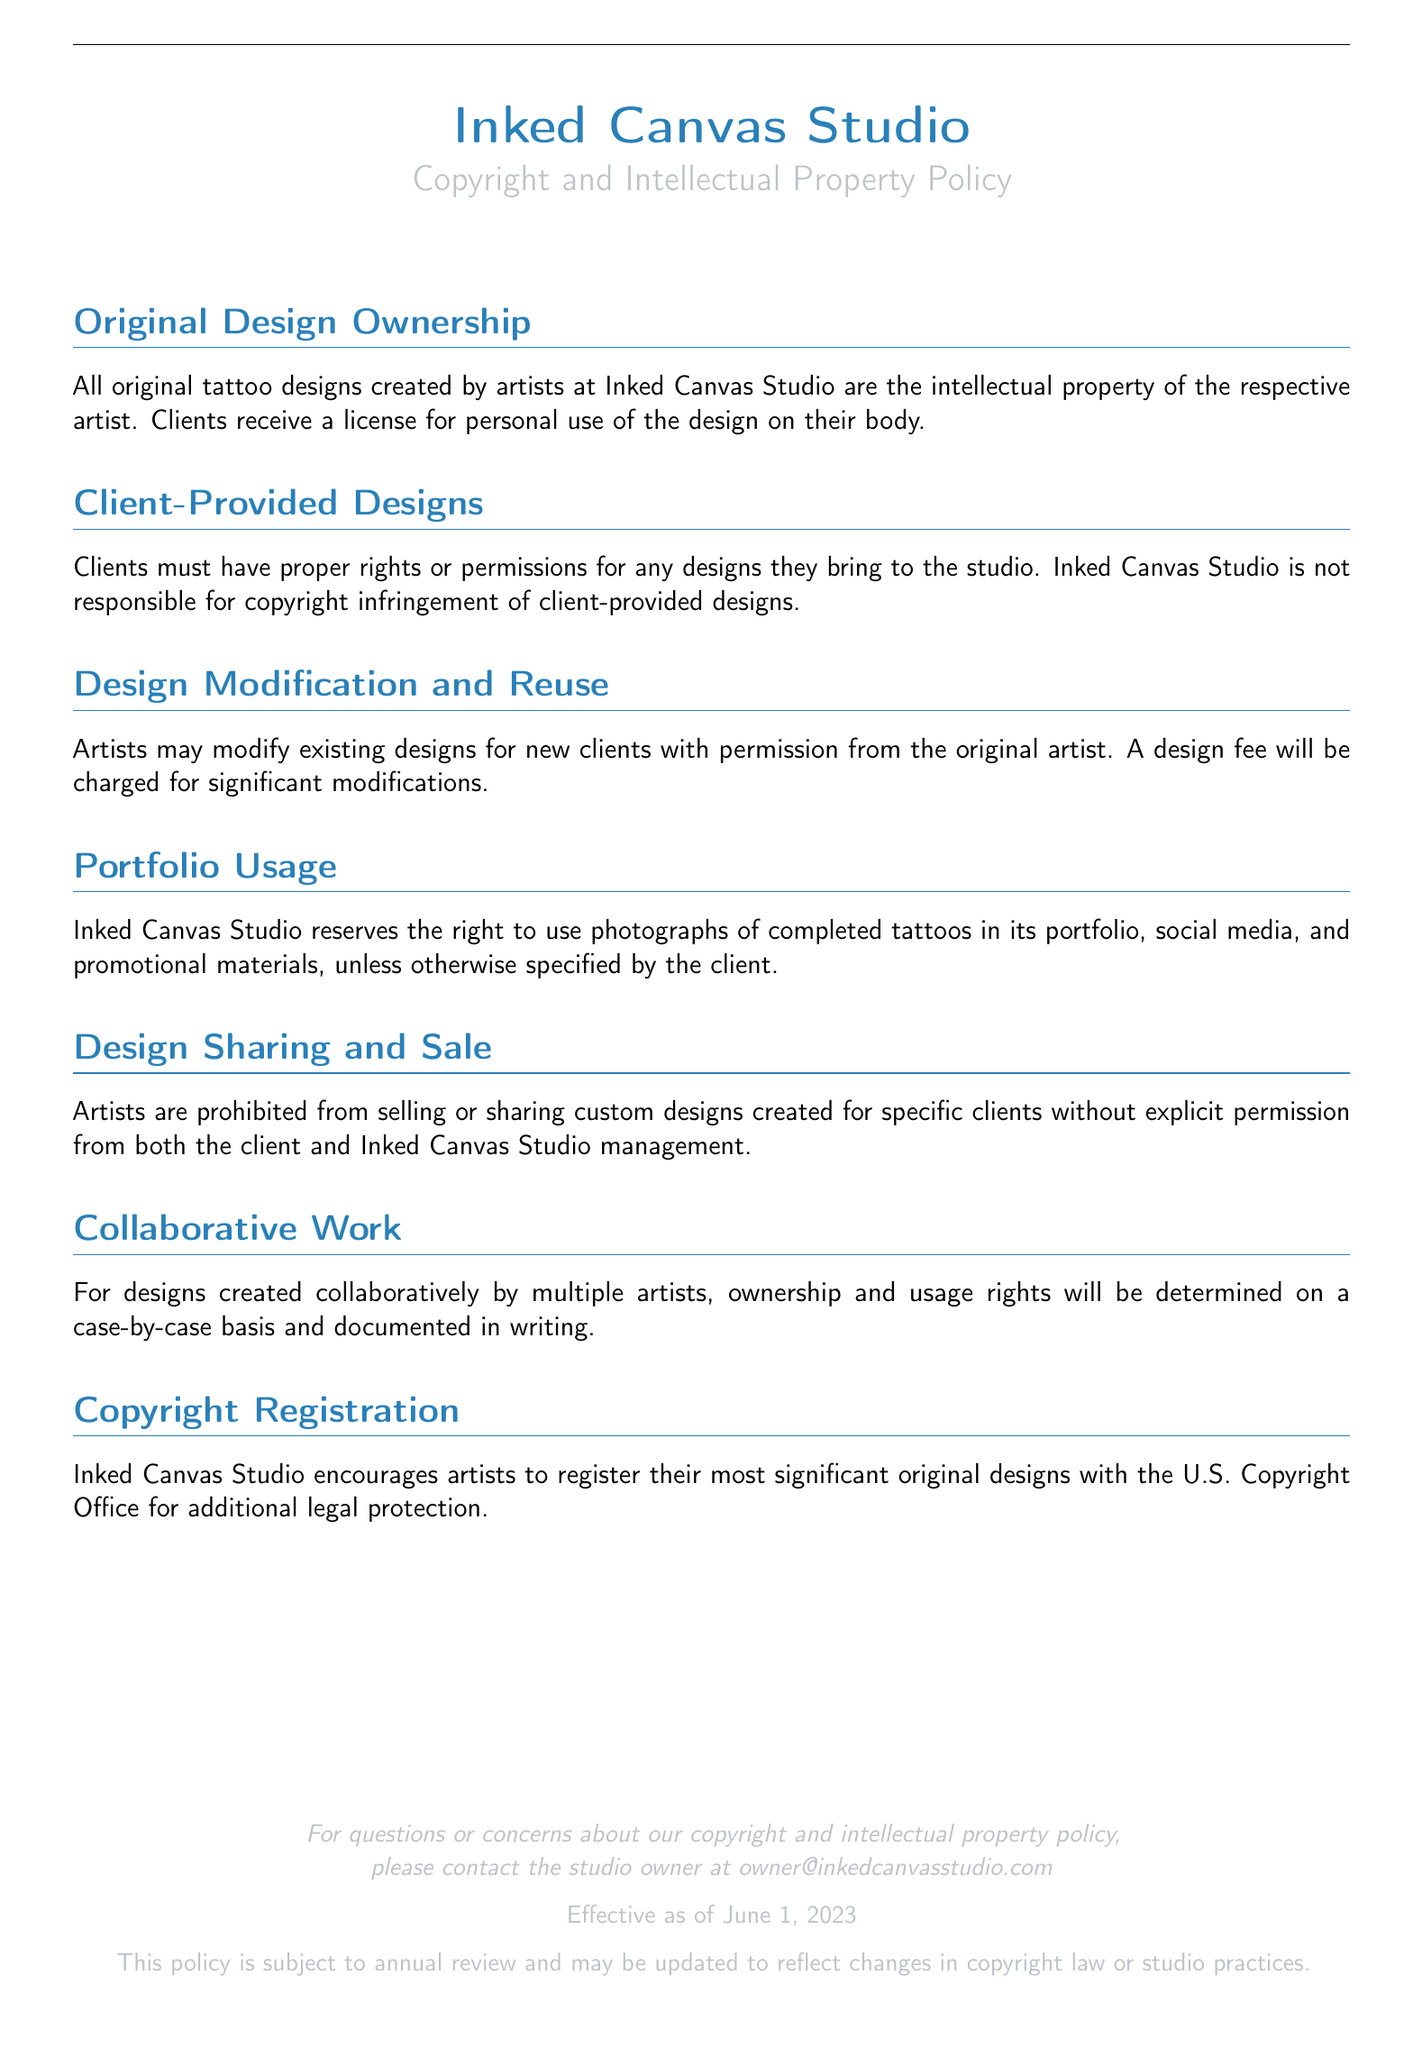What is the title of the document? The title is prominently displayed at the top of the document, which is "Copyright and Intellectual Property Policy."
Answer: Copyright and Intellectual Property Policy Who owns the original tattoo designs? The ownership of original designs is specified in the section titled "Original Design Ownership," indicating that the respective artist owns the designs.
Answer: The respective artist What must clients have for designs they provide? The document states under "Client-Provided Designs" that clients must have proper rights or permissions for any designs they bring.
Answer: Proper rights or permissions What is required for design modifications? The section "Design Modification and Reuse" mentions that artists need permission from the original artist for modifying designs.
Answer: Permission When does the policy become effective? The effective date of the policy is noted in the footer of the document.
Answer: June 1, 2023 What is encouraged for significant original designs? The document encourages artists to take specific action regarding their significant original designs as mentioned in the "Copyright Registration" section.
Answer: Registering Who can contact for questions about the policy? The document provides an email address for inquiries regarding the policy.
Answer: owner@inkedcanvasstudio.com Is there a design fee mentioned? The policy states a design fee is applicable for certain modifications which can be found in "Design Modification and Reuse."
Answer: Yes What happens to collaborative designs? The section on "Collaborative Work" addresses ownership and usage rights for designs created collaboratively, which are determined case-by-case.
Answer: Case-by-case basis 